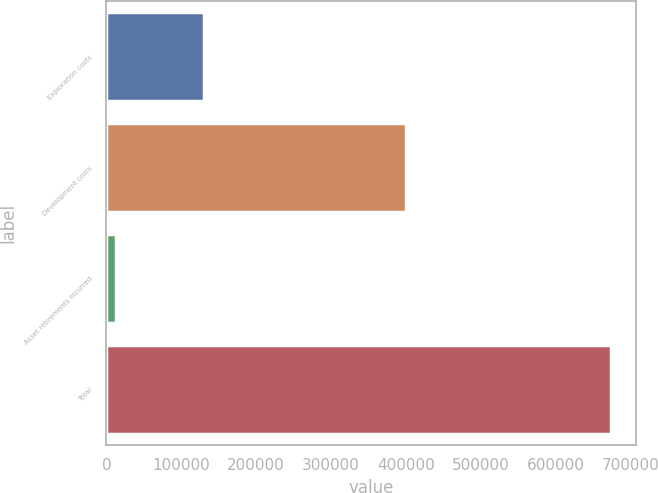Convert chart. <chart><loc_0><loc_0><loc_500><loc_500><bar_chart><fcel>Exploration costs<fcel>Development costs<fcel>Asset retirements incurred<fcel>Total<nl><fcel>129863<fcel>400477<fcel>13016<fcel>673822<nl></chart> 